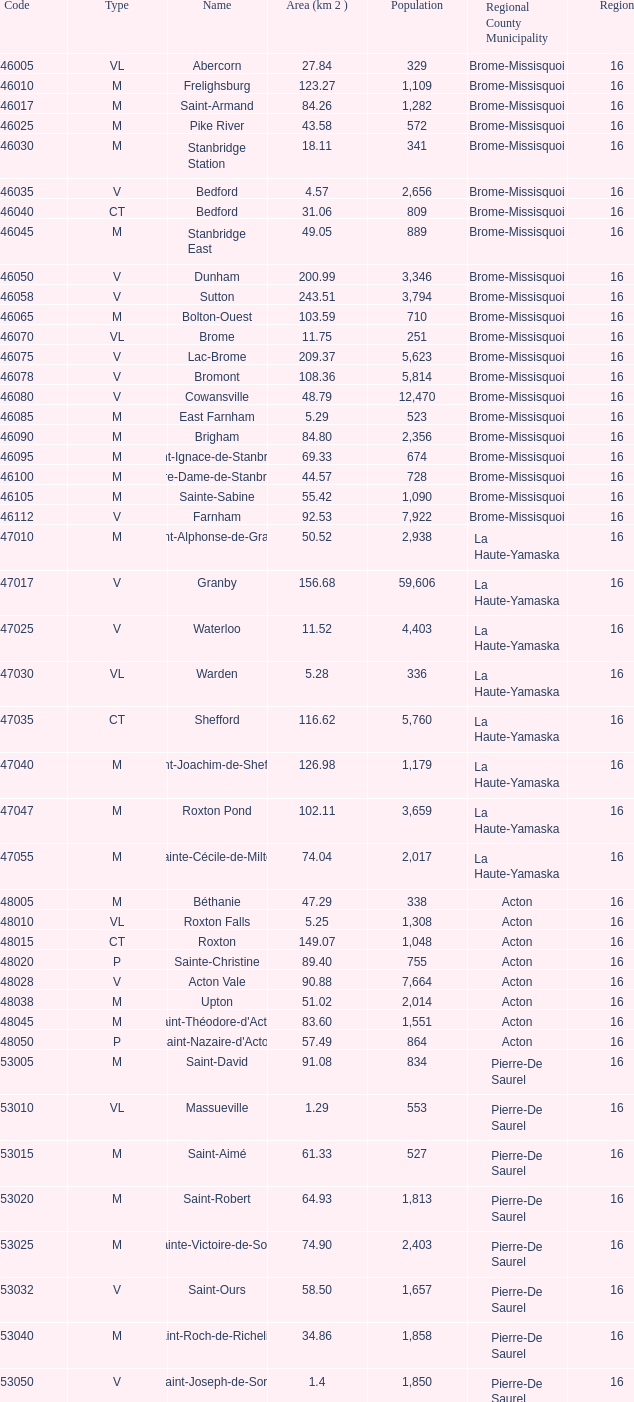Saint-Blaise-Sur-Richelieu is smaller than 68.42 km^2, what is the population of this type M municipality? None. 